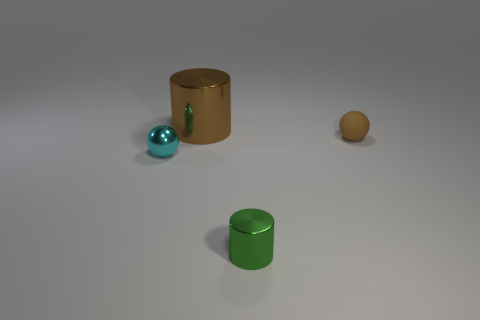Add 2 large metallic objects. How many objects exist? 6 Subtract all large brown metal cylinders. Subtract all rubber objects. How many objects are left? 2 Add 3 small brown things. How many small brown things are left? 4 Add 2 big purple rubber objects. How many big purple rubber objects exist? 2 Subtract 0 gray spheres. How many objects are left? 4 